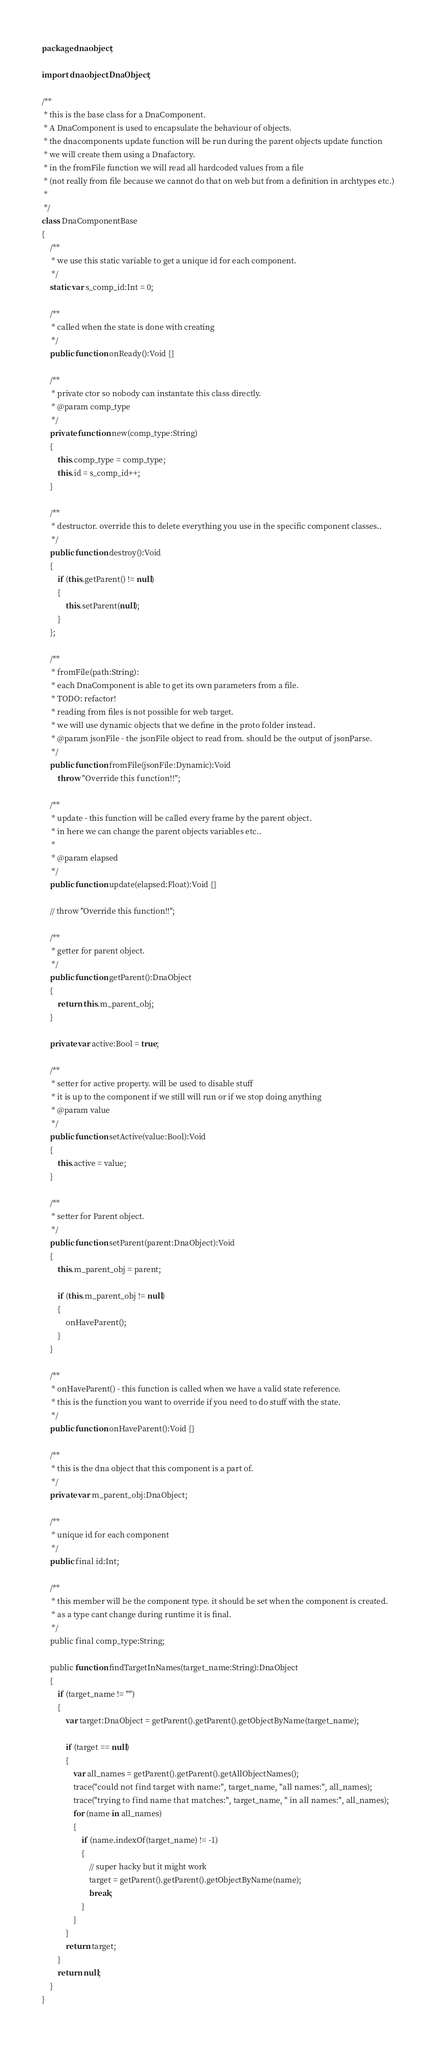<code> <loc_0><loc_0><loc_500><loc_500><_Haxe_>package dnaobject;

import dnaobject.DnaObject;

/**
 * this is the base class for a DnaComponent.
 * A DnaComponent is used to encapsulate the behaviour of objects.
 * the dnacomponents update function will be run during the parent objects update function
 * we will create them using a Dnafactory.
 * in the fromFile function we will read all hardcoded values from a file
 * (not really from file because we cannot do that on web but from a definition in archtypes etc.)
 *
 */
class DnaComponentBase
{
	/**
	 * we use this static variable to get a unique id for each component.
	 */
	static var s_comp_id:Int = 0;

	/**
	 * called when the state is done with creating
	 */
	public function onReady():Void {}

	/**
	 * private ctor so nobody can instantate this class directly.
	 * @param comp_type
	 */
	private function new(comp_type:String)
	{
		this.comp_type = comp_type;
		this.id = s_comp_id++;
	}

	/**
	 * destructor. override this to delete everything you use in the specific component classes..
	 */
	public function destroy():Void
	{
		if (this.getParent() != null)
		{
			this.setParent(null);
		}
	};

	/**
	 * fromFile(path:String):
	 * each DnaComponent is able to get its own parameters from a file.
	 * TODO: refactor!
	 * reading from files is not possible for web target.
	 * we will use dynamic objects that we define in the proto folder instead.
	 * @param jsonFile - the jsonFile object to read from. should be the output of jsonParse.
	 */
	public function fromFile(jsonFile:Dynamic):Void
		throw "Override this function!!";

	/**
	 * update - this function will be called every frame by the parent object.
	 * in here we can change the parent objects variables etc..
	 *
	 * @param elapsed
	 */
	public function update(elapsed:Float):Void {}

	// throw "Override this function!!";

	/**
	 * getter for parent object.
	 */
	public function getParent():DnaObject
	{
		return this.m_parent_obj;
	}

	private var active:Bool = true;

	/**
	 * setter for active property. will be used to disable stuff
	 * it is up to the component if we still will run or if we stop doing anything
	 * @param value
	 */
	public function setActive(value:Bool):Void
	{
		this.active = value;
	}

	/**
	 * setter for Parent object.
	 */
	public function setParent(parent:DnaObject):Void
	{
		this.m_parent_obj = parent;

		if (this.m_parent_obj != null)
		{
			onHaveParent();
		}
	}

	/**
	 * onHaveParent() - this function is called when we have a valid state reference.
	 * this is the function you want to override if you need to do stuff with the state.
	 */
	public function onHaveParent():Void {}

	/**
	 * this is the dna object that this component is a part of.
	 */
	private var m_parent_obj:DnaObject;

	/**
	 * unique id for each component
	 */
	public final id:Int;

	/**
	 * this member will be the component type. it should be set when the component is created.
	 * as a type cant change during runtime it is final.
	 */
	public final comp_type:String;

	public function findTargetInNames(target_name:String):DnaObject
	{
		if (target_name != "")
		{
			var target:DnaObject = getParent().getParent().getObjectByName(target_name);

			if (target == null)
			{
				var all_names = getParent().getParent().getAllObjectNames();
				trace("could not find target with name:", target_name, "all names:", all_names);
				trace("trying to find name that matches:", target_name, " in all names:", all_names);
				for (name in all_names)
				{
					if (name.indexOf(target_name) != -1)
					{
						// super hacky but it might work
						target = getParent().getParent().getObjectByName(name);
						break;
					}
				}
			}
			return target;
		}
		return null;
	}
}
</code> 